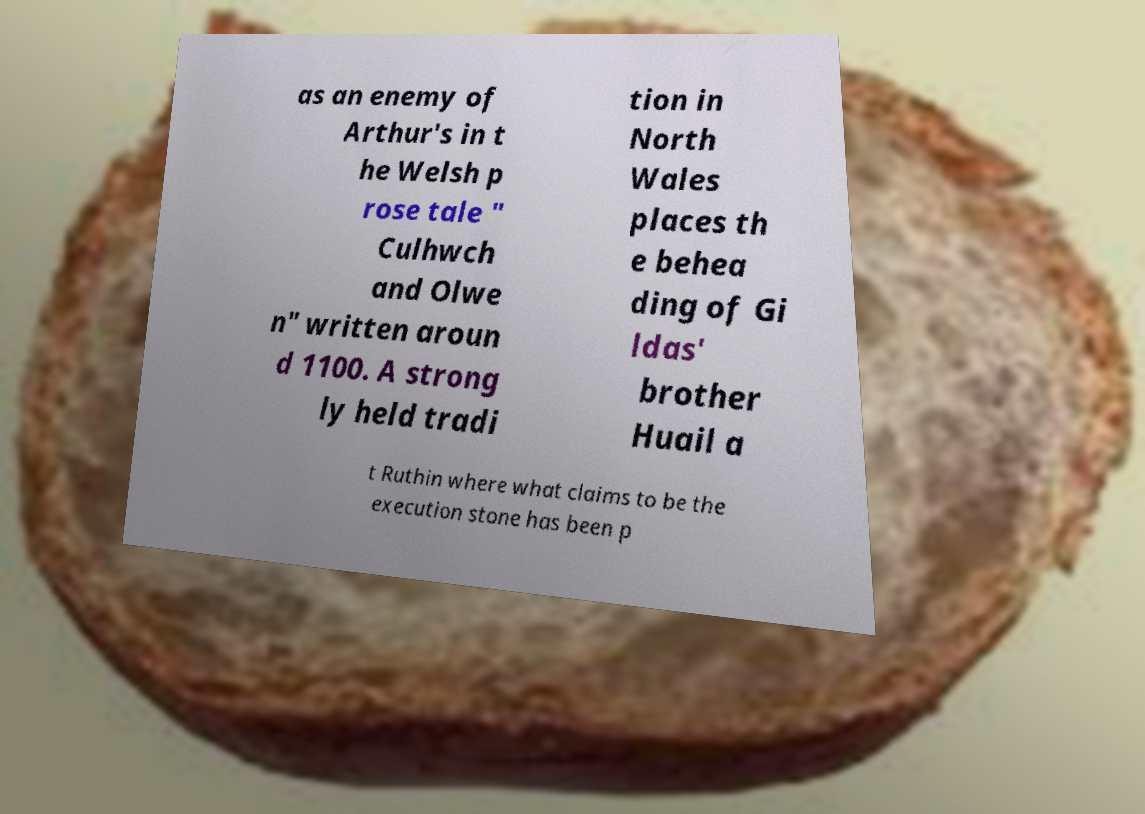Could you describe the historical significance of the beheading of Gildas' brother Huail? The story of the beheading of Gildas' brother Huail is part of Welsh folklore, with Huail often depicted as a rival of King Arthur. According to local tradition, the execution took place in Ruthin, and the event is commemorated by what is claimed to be the stone used for his execution. It's a piece of folklore that contributes to the area's cultural identity and historical interest, particularly for those intrigued by Arthurian legends and the historical figures that inspired them. 